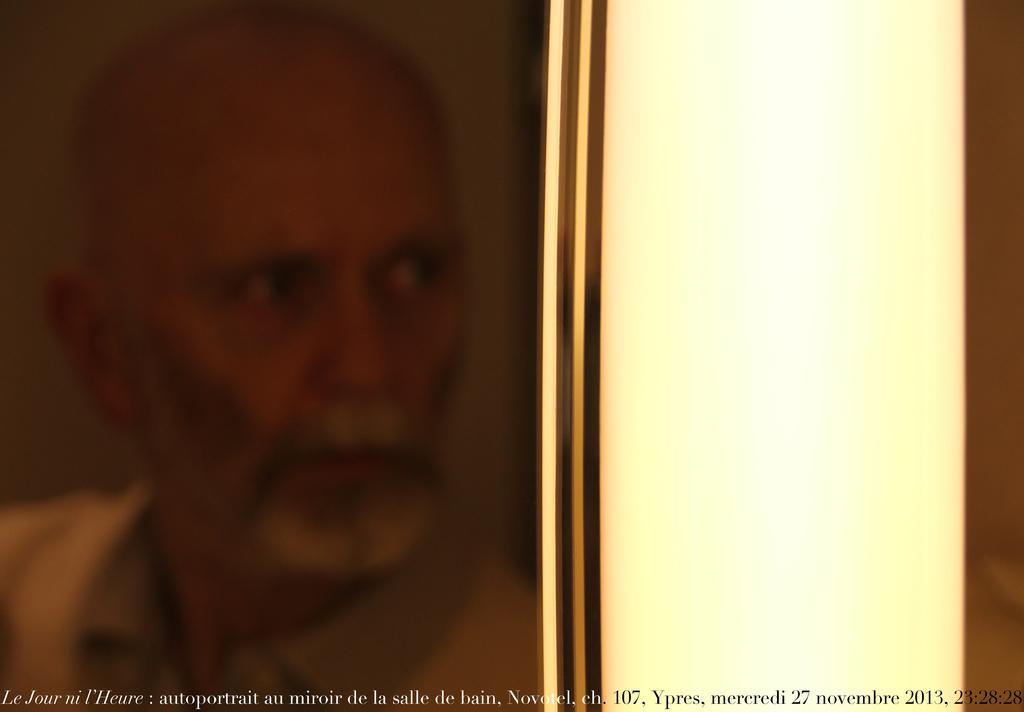Could you give a brief overview of what you see in this image? In this image we can see the person's frame. On the right there is wall and at the bottom there is text. 